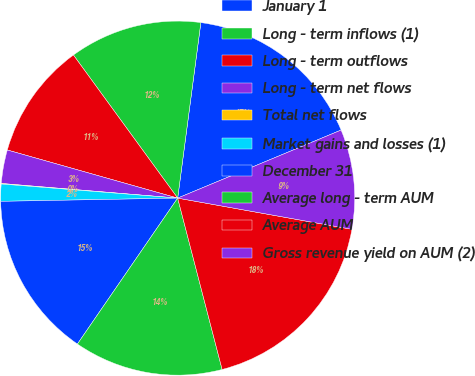<chart> <loc_0><loc_0><loc_500><loc_500><pie_chart><fcel>January 1<fcel>Long - term inflows (1)<fcel>Long - term outflows<fcel>Long - term net flows<fcel>Total net flows<fcel>Market gains and losses (1)<fcel>December 31<fcel>Average long - term AUM<fcel>Average AUM<fcel>Gross revenue yield on AUM (2)<nl><fcel>16.63%<fcel>12.11%<fcel>10.6%<fcel>3.06%<fcel>0.05%<fcel>1.56%<fcel>15.13%<fcel>13.62%<fcel>18.14%<fcel>9.1%<nl></chart> 